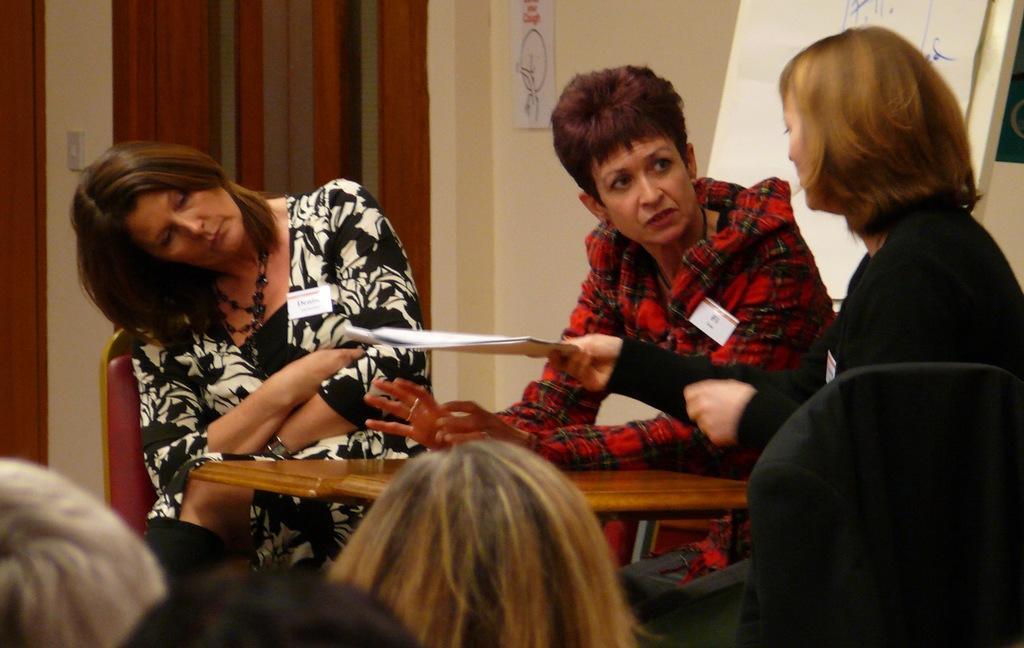Describe this image in one or two sentences. There are three women sitting on the chairs. This is the wooden table. I can see the woman holding a paper. This looks like a board. Here is a paper, which is attached to the wall. I think this is the door. At the bottom of the image, I can see few people heads. 